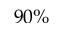Convert formula to latex. <formula><loc_0><loc_0><loc_500><loc_500>9 0 \%</formula> 